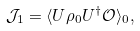Convert formula to latex. <formula><loc_0><loc_0><loc_500><loc_500>\mathcal { J } _ { 1 } = \langle U \rho _ { 0 } U ^ { \dagger } \mathcal { O } \rangle _ { 0 } ,</formula> 